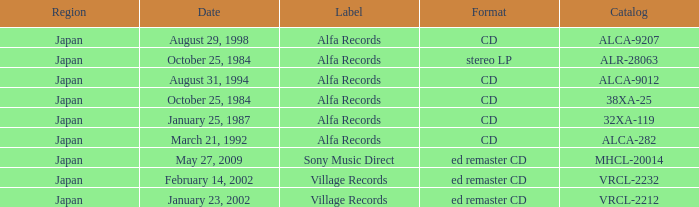What is the catalog of the release from January 23, 2002? VRCL-2212. 